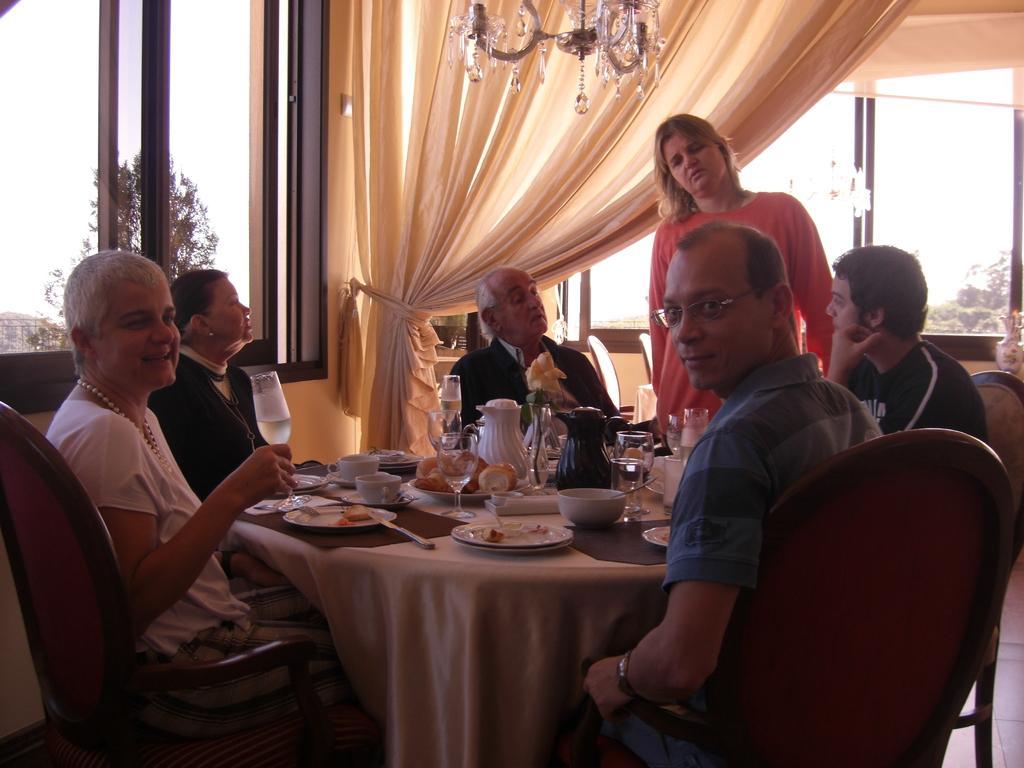Could you give a brief overview of what you see in this image? On the background we can see windows, curtain. This is a ceiling lamp. Here we can see few persons sitting on chairs in front of a table and on the table we can see bowls, plate of food, jars, flower vase. We can see one woman standing near to the table. Through the window glass we can see trees. 